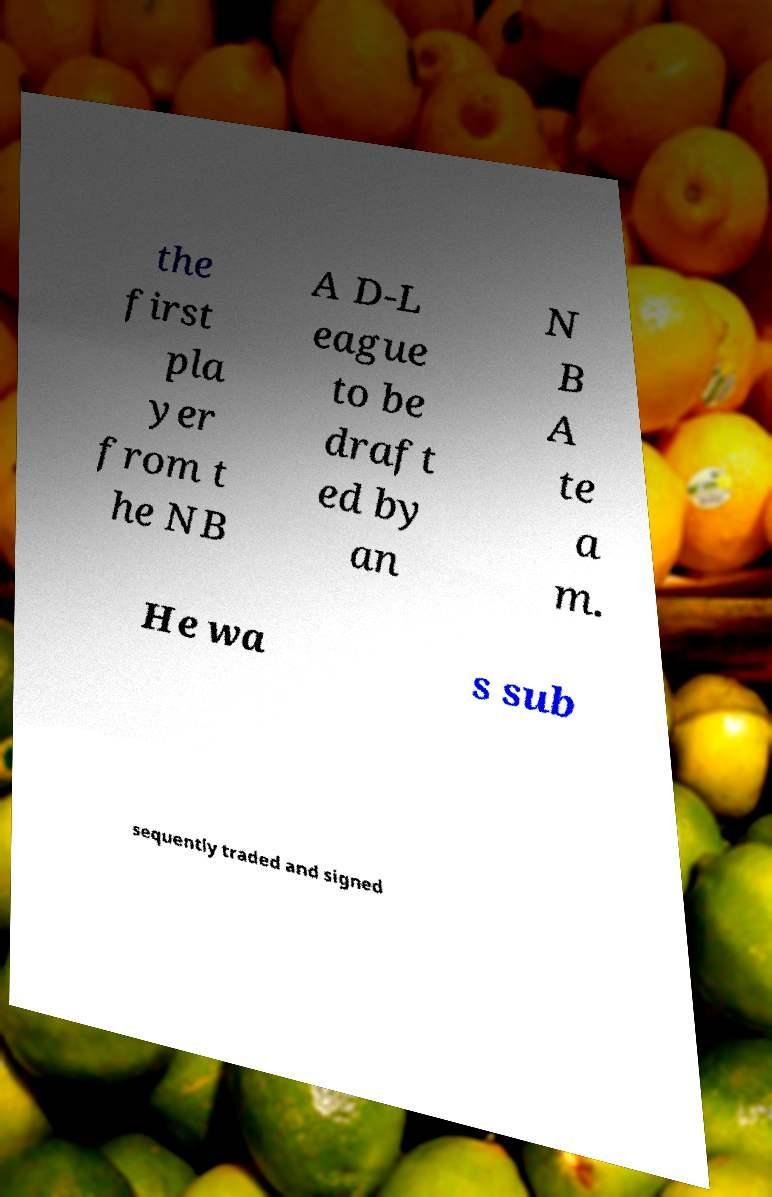For documentation purposes, I need the text within this image transcribed. Could you provide that? the first pla yer from t he NB A D-L eague to be draft ed by an N B A te a m. He wa s sub sequently traded and signed 